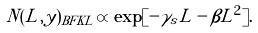<formula> <loc_0><loc_0><loc_500><loc_500>\tilde { N } ( L , y ) _ { B F K L } \varpropto \exp [ - \gamma _ { s } L - \beta L ^ { 2 } ] .</formula> 